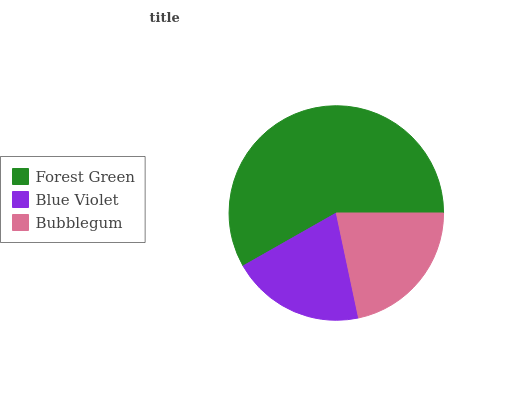Is Blue Violet the minimum?
Answer yes or no. Yes. Is Forest Green the maximum?
Answer yes or no. Yes. Is Bubblegum the minimum?
Answer yes or no. No. Is Bubblegum the maximum?
Answer yes or no. No. Is Bubblegum greater than Blue Violet?
Answer yes or no. Yes. Is Blue Violet less than Bubblegum?
Answer yes or no. Yes. Is Blue Violet greater than Bubblegum?
Answer yes or no. No. Is Bubblegum less than Blue Violet?
Answer yes or no. No. Is Bubblegum the high median?
Answer yes or no. Yes. Is Bubblegum the low median?
Answer yes or no. Yes. Is Blue Violet the high median?
Answer yes or no. No. Is Forest Green the low median?
Answer yes or no. No. 